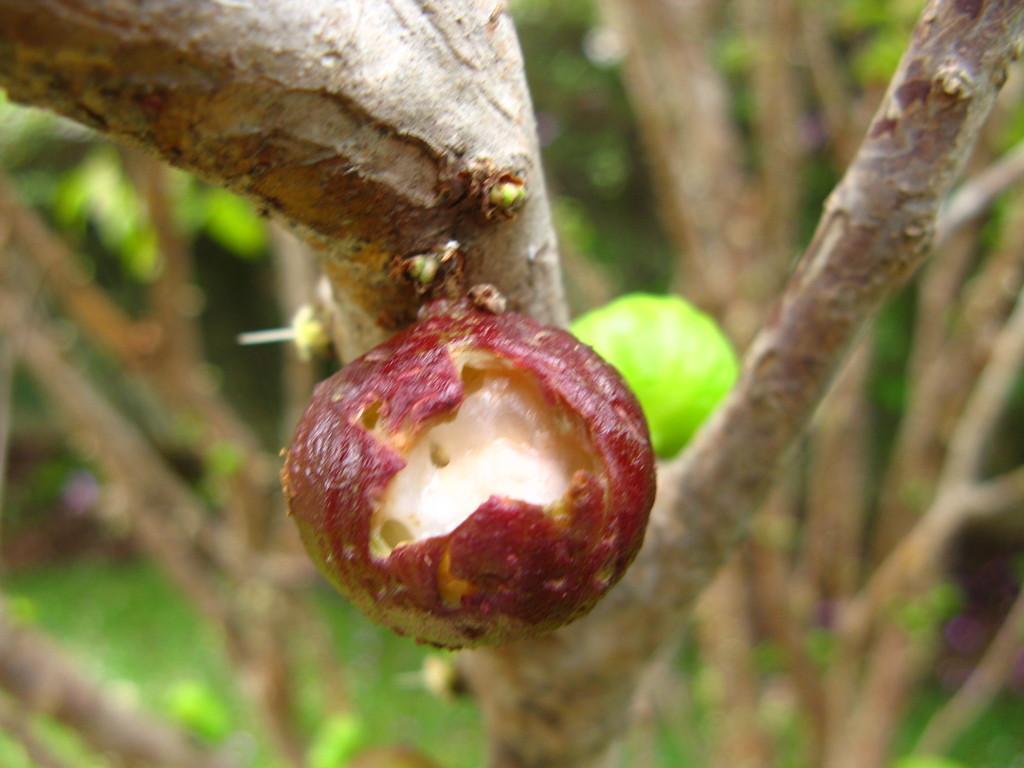How would you summarize this image in a sentence or two? There is a tree with a fruit on it. In the background it is blurred. Also we can see few trees. 